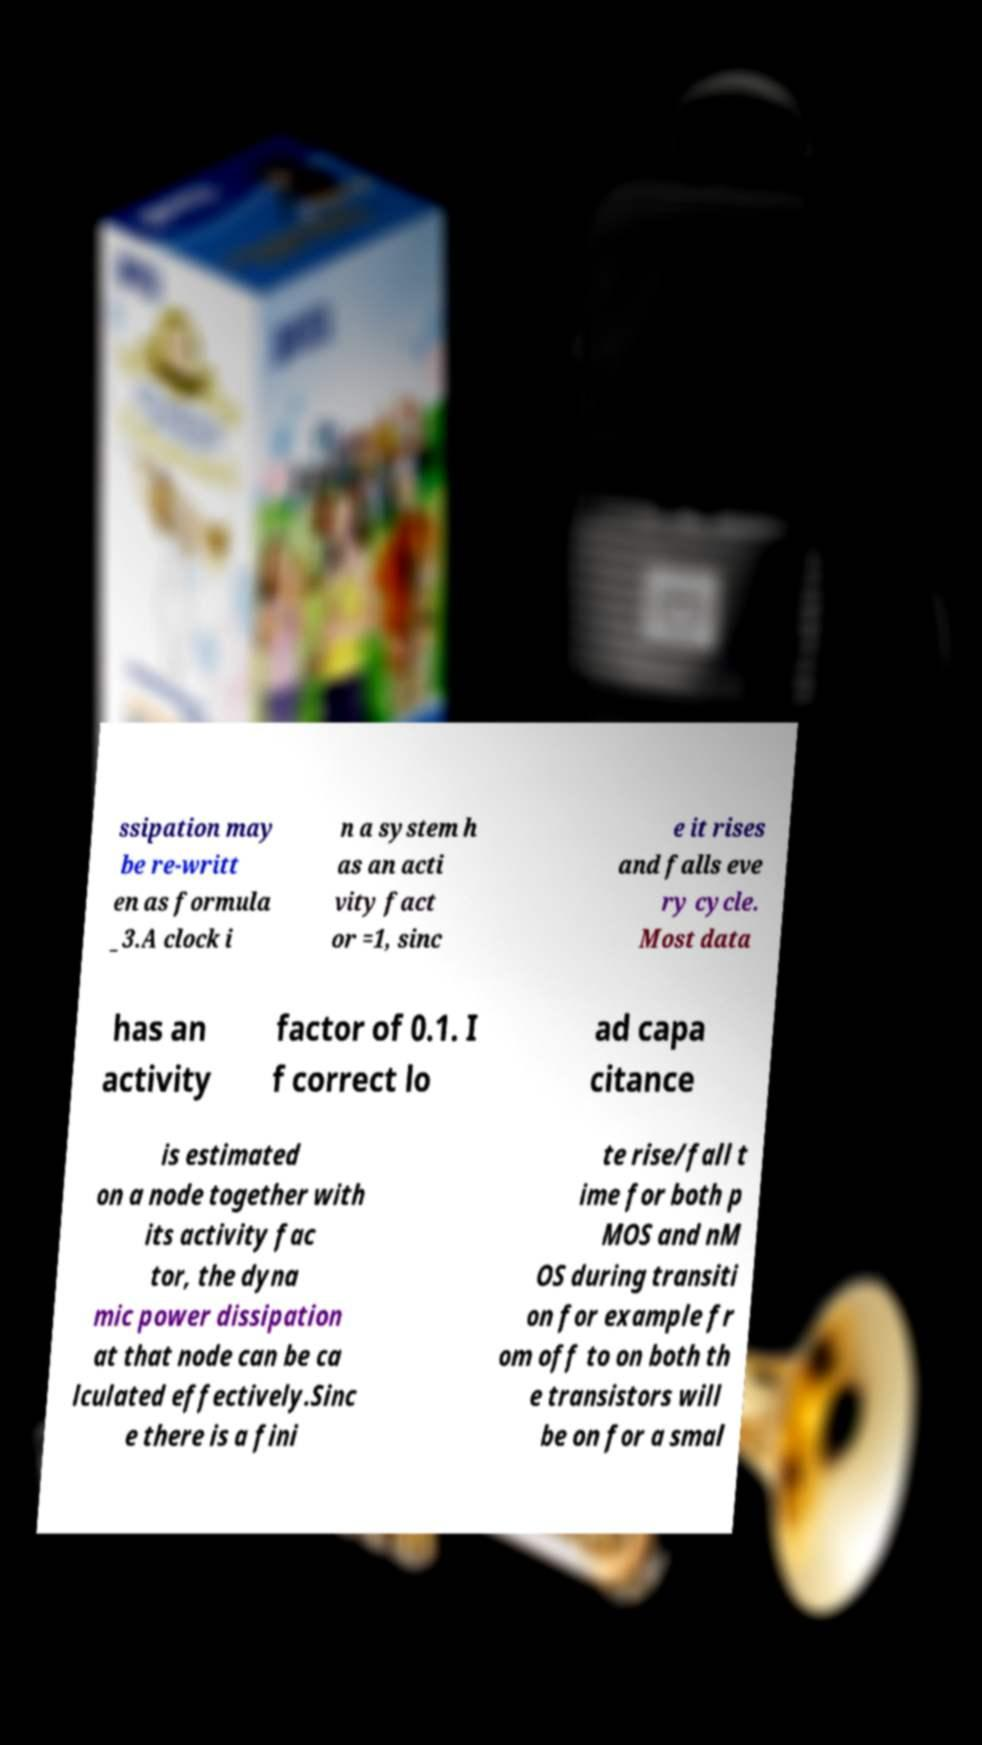Please read and relay the text visible in this image. What does it say? ssipation may be re-writt en as formula _3.A clock i n a system h as an acti vity fact or =1, sinc e it rises and falls eve ry cycle. Most data has an activity factor of 0.1. I f correct lo ad capa citance is estimated on a node together with its activity fac tor, the dyna mic power dissipation at that node can be ca lculated effectively.Sinc e there is a fini te rise/fall t ime for both p MOS and nM OS during transiti on for example fr om off to on both th e transistors will be on for a smal 